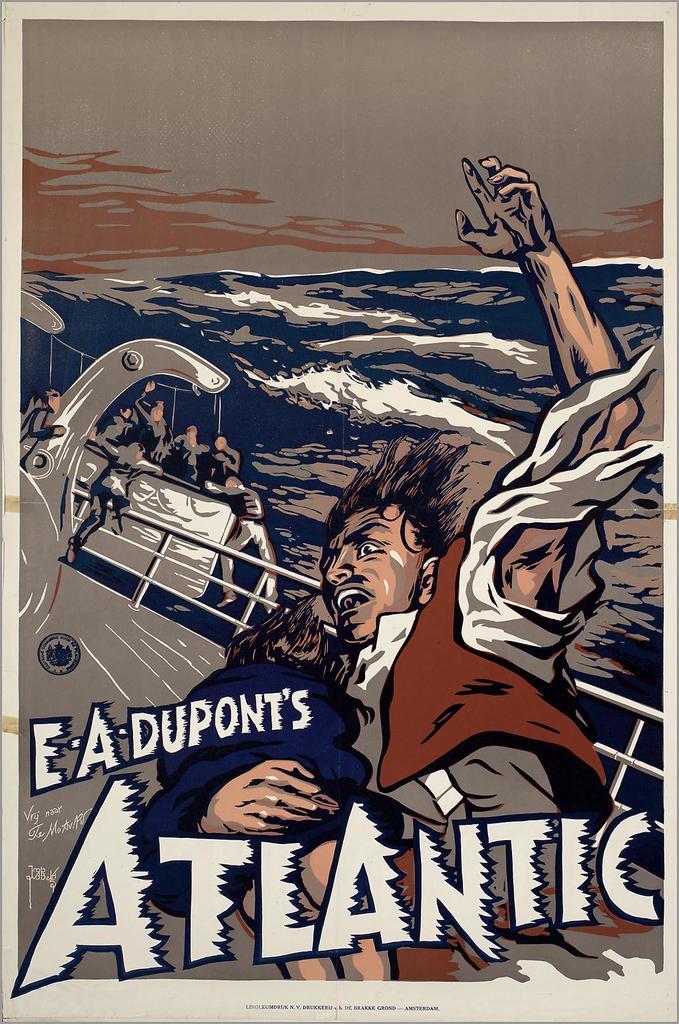What is this advertising?
Give a very brief answer. Atlantic. 